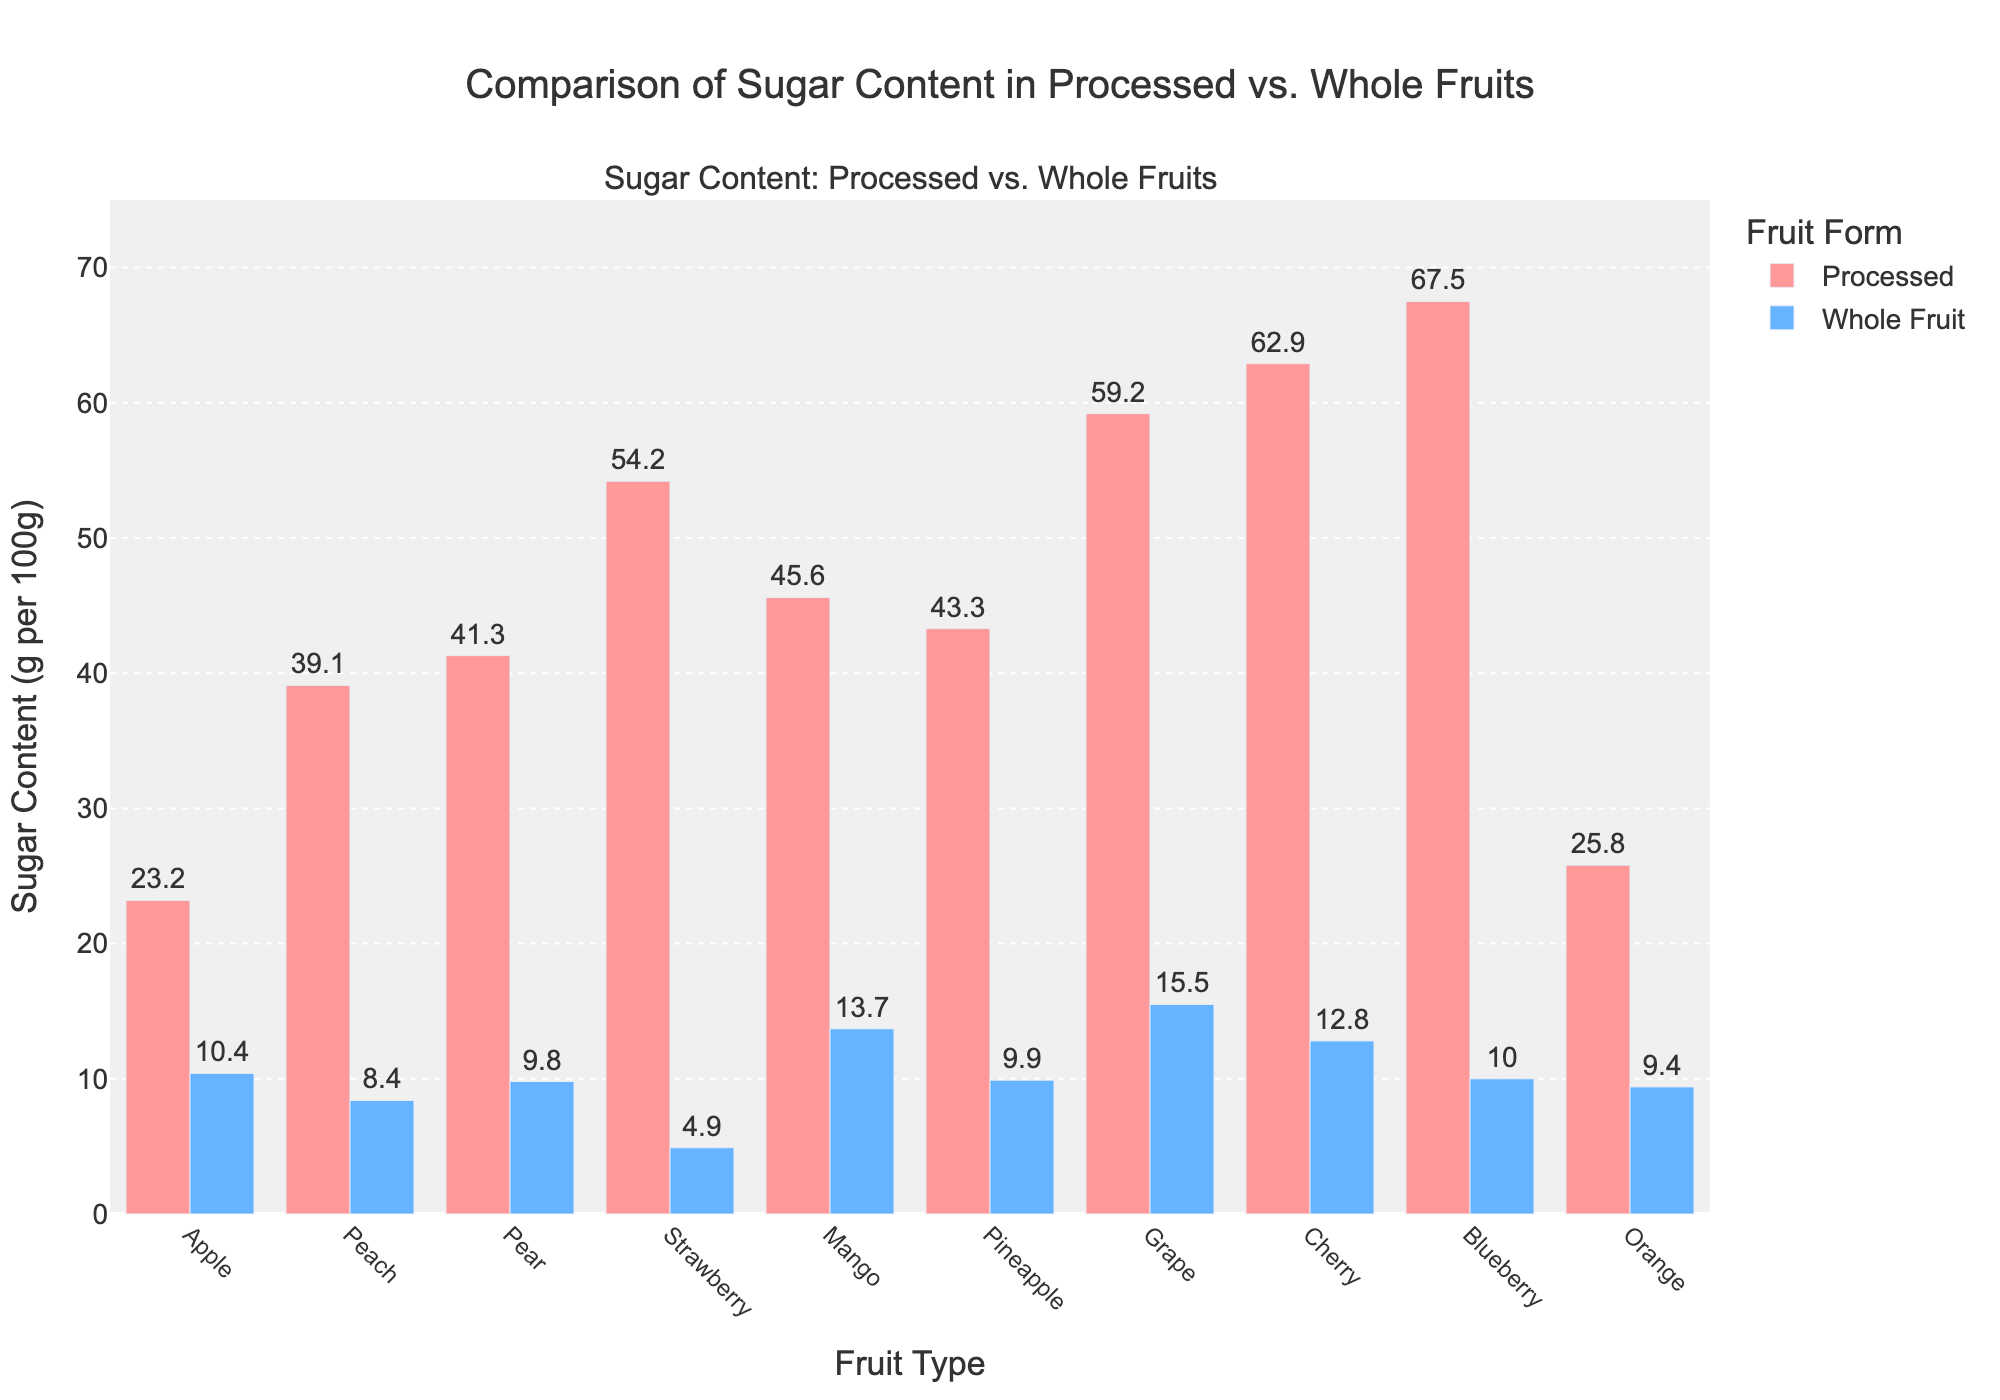Which fruit has the highest sugar content in its processed form? Examine the height of the bars for processed fruits. The highest bar represents the fruit with the highest sugar content in processed form. Here, the bar for Blueberry is the tallest.
Answer: Blueberry Which fruit has the lowest sugar content in its whole form? Look at the height of the bars for whole fruits. The shortest bar indicates the fruit with the lowest sugar content in its whole form. The bar for Strawberry is the shortest.
Answer: Strawberry How much more sugar does a processed Peach have compared to a whole Peach? Find the heights of the bars for both processed Peach and whole Peach, then subtract the whole fruit value from the processed value. 39.1 (Processed Peach) - 8.4 (Whole Peach) = 30.7
Answer: 30.7 g per 100g Compare the sugar content difference between processed and whole Grapes and processed and whole Cherries. Which has a larger difference? Subtract the whole fruit sugar content from the processed sugar content for both Grapes and Cherries, then compare the results. Grape: 59.2 - 15.5 = 43.7; Cherry: 62.9 - 12.8 = 50.1. Thus, Cherries have a larger difference.
Answer: Cherries Which category (processed or whole fruit) shows more variation in sugar content? Assess the spread of the bar heights in both categories. The processed fruit bars vary more significantly in height compared to whole fruit bars, indicating more variation.
Answer: Processed What is the average sugar content of whole fruits shown in the chart? Sum the sugar content values for whole fruits and divide by the number of fruits. (10.4 + 8.4 + 9.8 + 4.9 + 13.7 + 9.9 + 15.5 + 12.8 + 10.0 + 9.4) / 10 = 9.48 g per 100g
Answer: 9.48 g per 100g Which fruit shows the smallest difference in sugar content between processed and whole forms? Calculate the differences in sugar content for each fruit and identify the smallest. The differences are as follows: Apple: 12.8, Peach: 30.7, Pear: 31.5, Strawberry: 49.3, Mango: 31.9, Pineapple: 33.4, Grape: 43.7, Cherry: 50.1, Blueberry: 57.5, Orange: 16.4. The smallest difference is for Apple (12.8).
Answer: Apple 